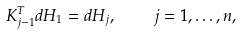Convert formula to latex. <formula><loc_0><loc_0><loc_500><loc_500>K _ { j - 1 } ^ { T } d H _ { 1 } = d H _ { j } , \quad j = 1 , \dots , n ,</formula> 